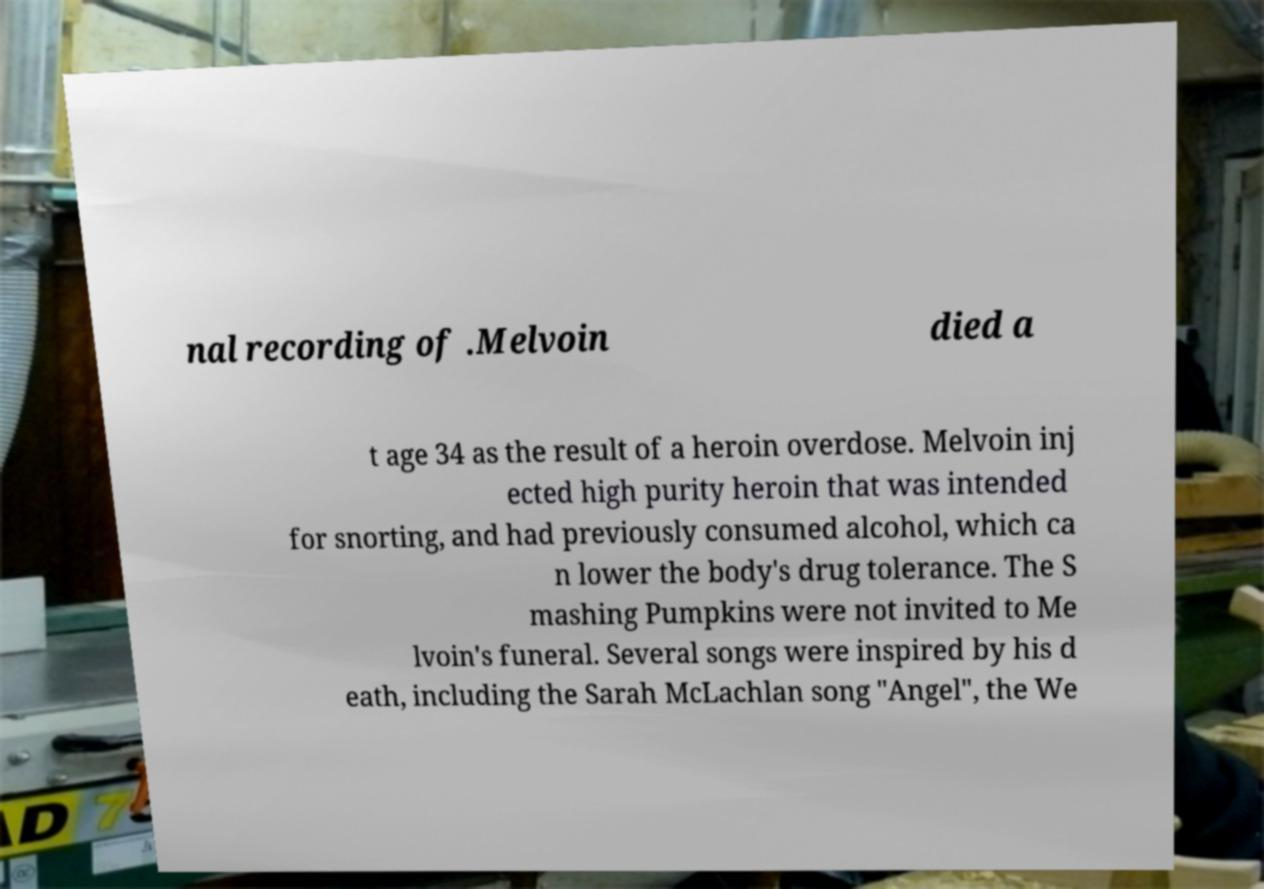I need the written content from this picture converted into text. Can you do that? nal recording of .Melvoin died a t age 34 as the result of a heroin overdose. Melvoin inj ected high purity heroin that was intended for snorting, and had previously consumed alcohol, which ca n lower the body's drug tolerance. The S mashing Pumpkins were not invited to Me lvoin's funeral. Several songs were inspired by his d eath, including the Sarah McLachlan song "Angel", the We 